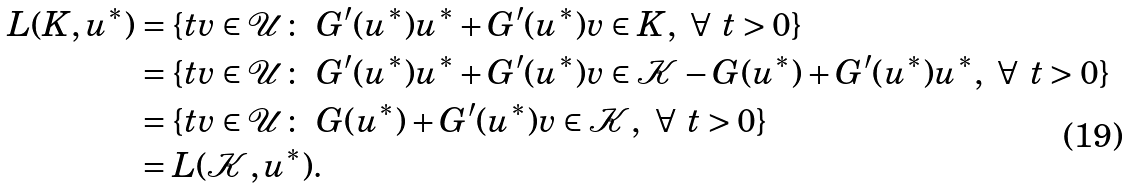Convert formula to latex. <formula><loc_0><loc_0><loc_500><loc_500>L ( K , u ^ { * } ) & = \{ t v \in \mathcal { U } \colon \ G ^ { \prime } ( u ^ { * } ) u ^ { * } + G ^ { \prime } ( u ^ { * } ) v \in K , \ \forall \ t > 0 \} \\ & = \{ t v \in \mathcal { U } \colon \ G ^ { \prime } ( u ^ { * } ) u ^ { * } + G ^ { \prime } ( u ^ { * } ) v \in \mathcal { K } - G ( u ^ { * } ) + G ^ { \prime } ( u ^ { * } ) u ^ { * } , \ \forall \ t > 0 \} \\ & = \{ t v \in \mathcal { U } \colon \ G ( u ^ { * } ) + G ^ { \prime } ( u ^ { * } ) v \in \mathcal { K } , \ \forall \ t > 0 \} \\ & = L ( \mathcal { K } , u ^ { * } ) .</formula> 